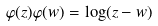Convert formula to latex. <formula><loc_0><loc_0><loc_500><loc_500>\varphi ( z ) \varphi ( w ) = \log ( z - w )</formula> 